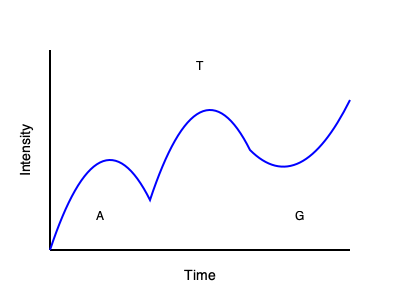Analyze the electropherogram above. What is the most likely nucleotide sequence represented by the peaks, assuming this is a 5' to 3' read direction? 1. Interpret the electropherogram:
   - The x-axis represents time, which correlates with fragment size in DNA sequencing.
   - The y-axis represents signal intensity, indicating the presence of a specific nucleotide.
   - Each peak corresponds to a nucleotide in the DNA sequence.

2. Identify peaks from left to right:
   - First peak: Labeled "A" (Adenine)
   - Second peak: Labeled "T" (Thymine)
   - Third peak: Labeled "G" (Guanine)

3. Consider the 5' to 3' read direction:
   - In DNA sequencing, the fragments are typically read from the 5' end to the 3' end.
   - The order of peaks from left to right represents the sequence in the 5' to 3' direction.

4. Determine the sequence:
   - The peaks appear in the order: A, T, G
   - This directly translates to the nucleotide sequence: ATG

5. Verify the result:
   - ATG is a common start codon in DNA, which supports the likelihood of this being the correct sequence.
Answer: ATG 